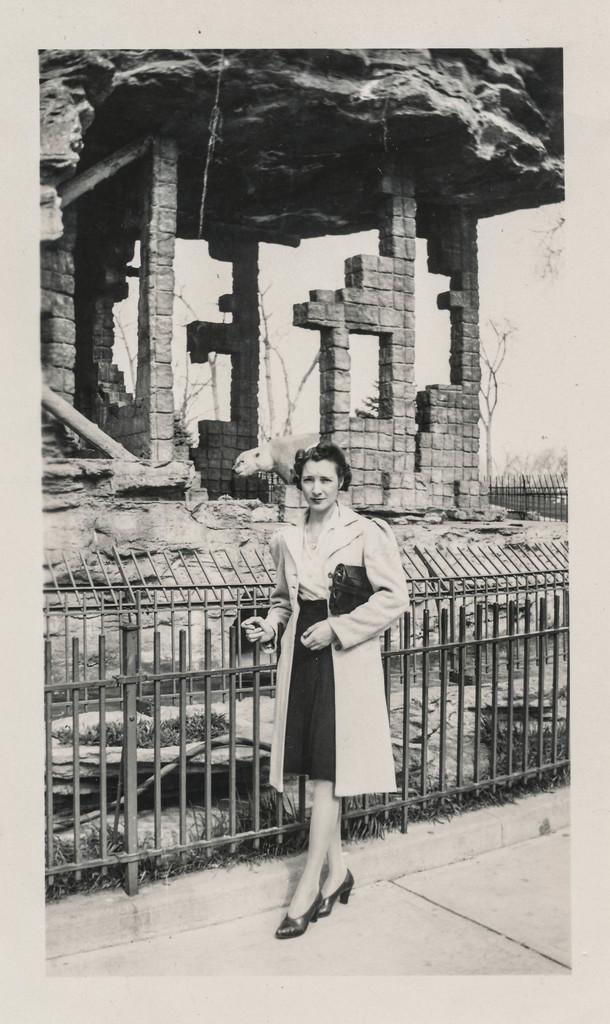What is the main subject of the image? There is a person in the image. Can you describe the person's attire? The person is wearing clothes. What is behind the person in the image? The person is standing in front of a fence. What other living creature can be seen in the image? There is an animal in the image. What type of structure is visible in the background? There is an ancient building in the image. What type of bait is the person using to catch the animal in the image? There is no indication in the image that the person is trying to catch the animal or using any bait. 